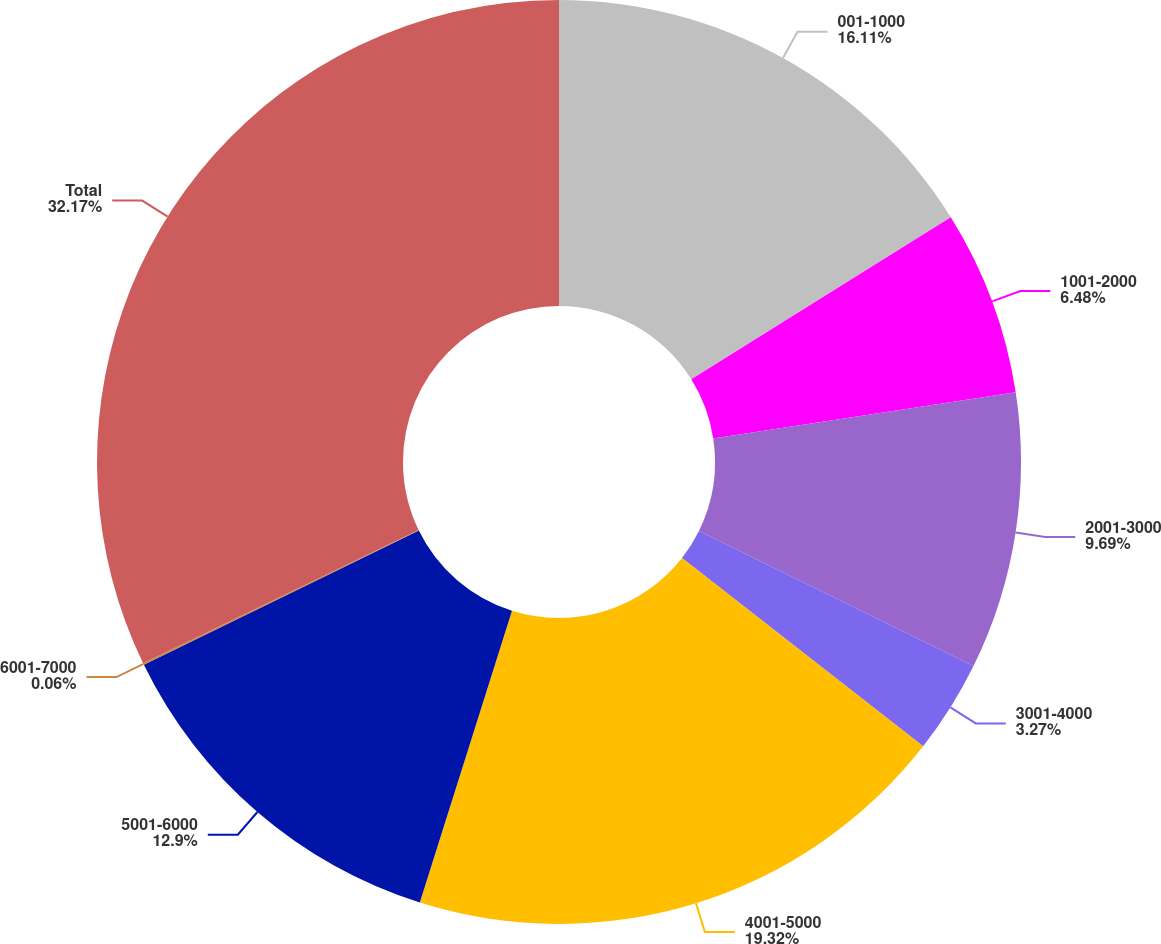Convert chart to OTSL. <chart><loc_0><loc_0><loc_500><loc_500><pie_chart><fcel>001-1000<fcel>1001-2000<fcel>2001-3000<fcel>3001-4000<fcel>4001-5000<fcel>5001-6000<fcel>6001-7000<fcel>Total<nl><fcel>16.11%<fcel>6.48%<fcel>9.69%<fcel>3.27%<fcel>19.32%<fcel>12.9%<fcel>0.06%<fcel>32.17%<nl></chart> 